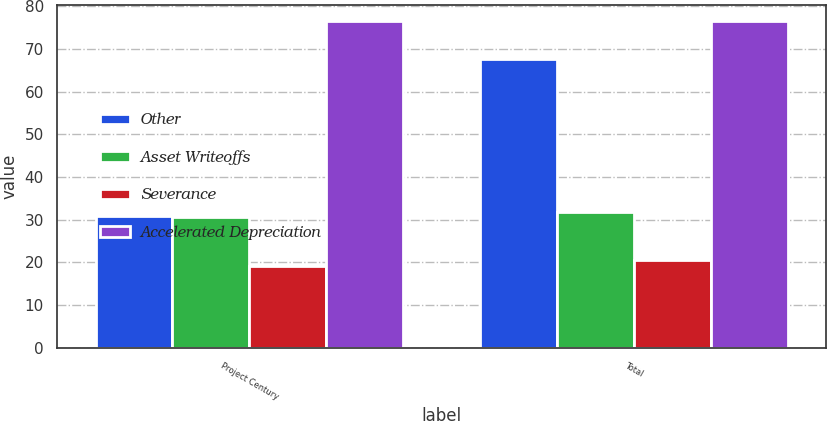Convert chart to OTSL. <chart><loc_0><loc_0><loc_500><loc_500><stacked_bar_chart><ecel><fcel>Project Century<fcel>Total<nl><fcel>Other<fcel>30.9<fcel>67.6<nl><fcel>Asset Writeoffs<fcel>30.7<fcel>31.9<nl><fcel>Severance<fcel>19.1<fcel>20.5<nl><fcel>Accelerated Depreciation<fcel>76.5<fcel>76.5<nl></chart> 